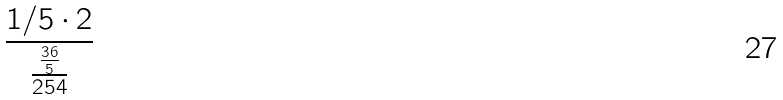<formula> <loc_0><loc_0><loc_500><loc_500>\frac { 1 / 5 \cdot 2 } { \frac { \frac { 3 6 } { 5 } } { 2 5 4 } }</formula> 